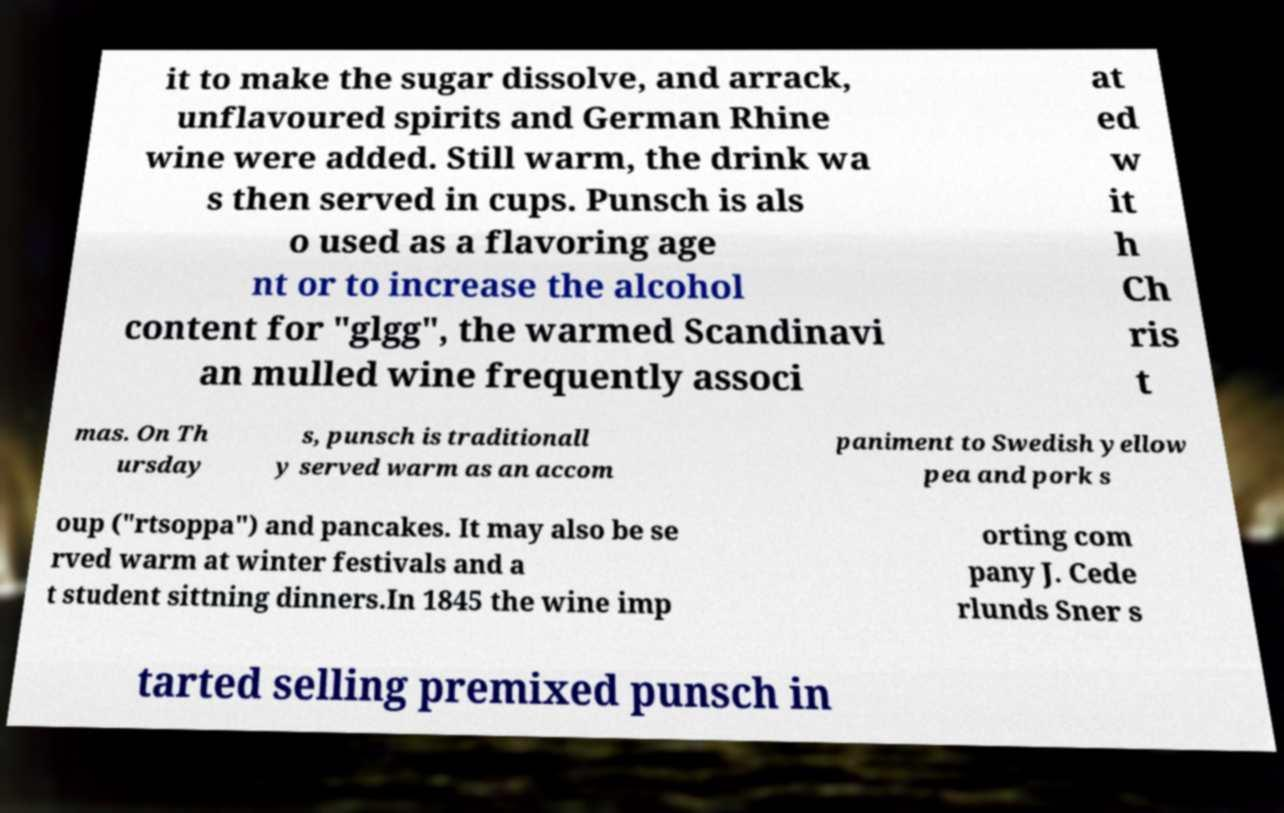What messages or text are displayed in this image? I need them in a readable, typed format. it to make the sugar dissolve, and arrack, unflavoured spirits and German Rhine wine were added. Still warm, the drink wa s then served in cups. Punsch is als o used as a flavoring age nt or to increase the alcohol content for "glgg", the warmed Scandinavi an mulled wine frequently associ at ed w it h Ch ris t mas. On Th ursday s, punsch is traditionall y served warm as an accom paniment to Swedish yellow pea and pork s oup ("rtsoppa") and pancakes. It may also be se rved warm at winter festivals and a t student sittning dinners.In 1845 the wine imp orting com pany J. Cede rlunds Sner s tarted selling premixed punsch in 